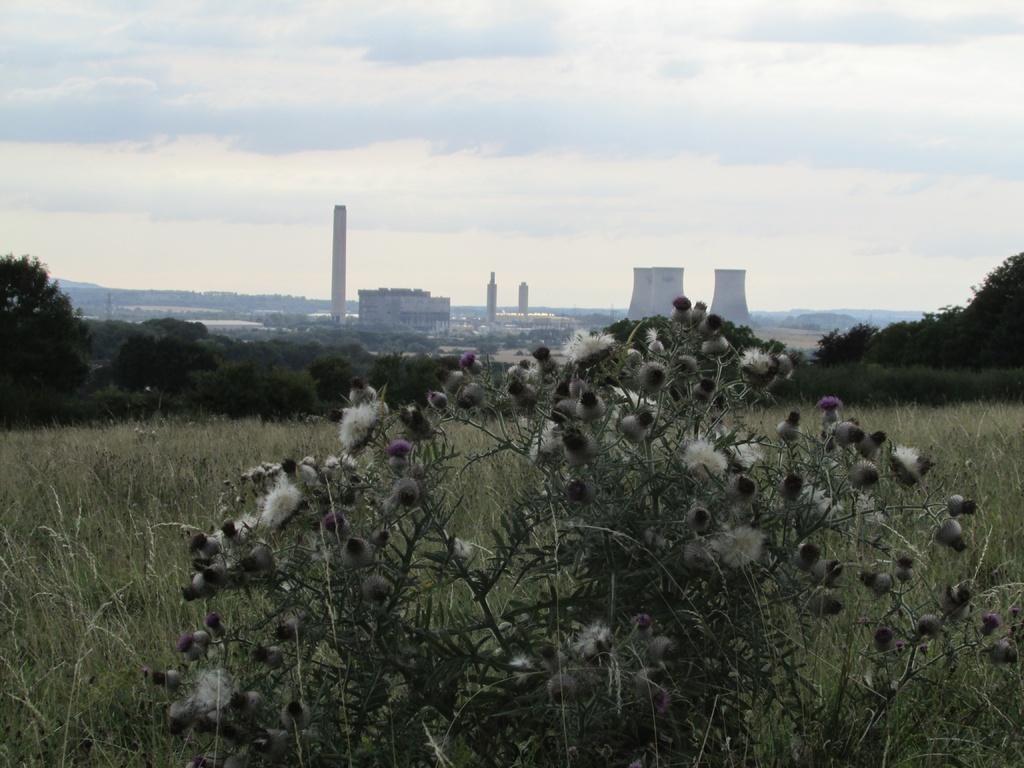Could you give a brief overview of what you see in this image? In this image in the foreground there is a plant, and in the background there are plants, trees, buildings, towers and at the top there is sky. 